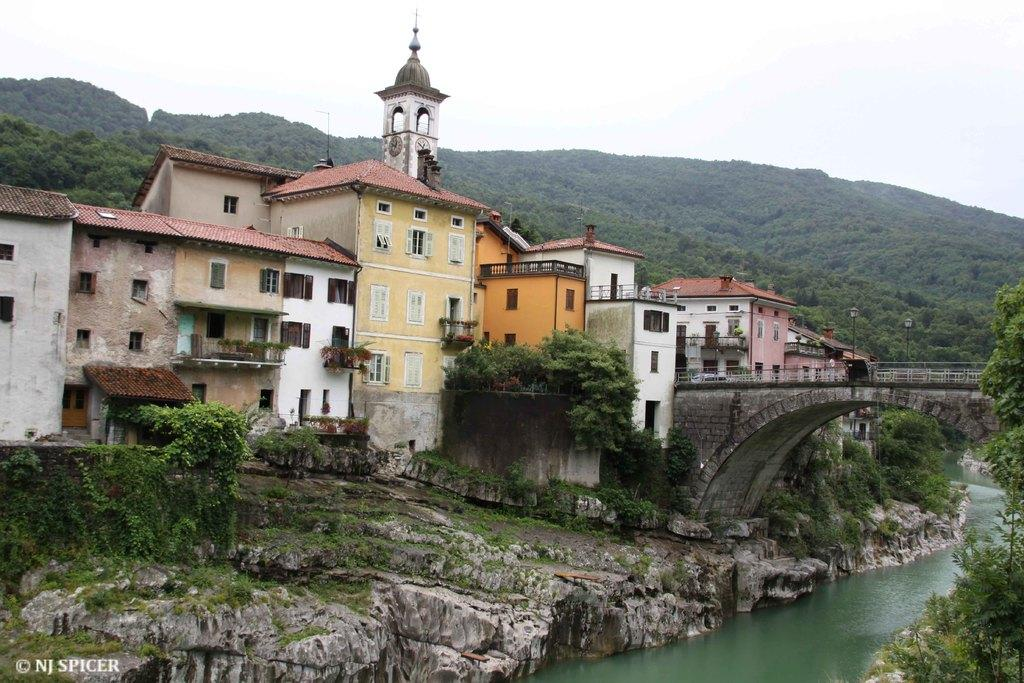What is the main feature of the image? There is water in the image. What structure can be seen crossing the water? There is a bridge at the center of the image. What can be seen in the distance behind the bridge? There are buildings and trees in the background of the image. What else is visible in the background of the image? The sky is visible in the background of the image. Can you see a baby playing with a cat on the bridge in the image? No, there is no baby or cat present on the bridge in the image. What type of drum is being played by the person standing on the bridge? There is no drum or person playing a drum visible on the bridge in the image. 